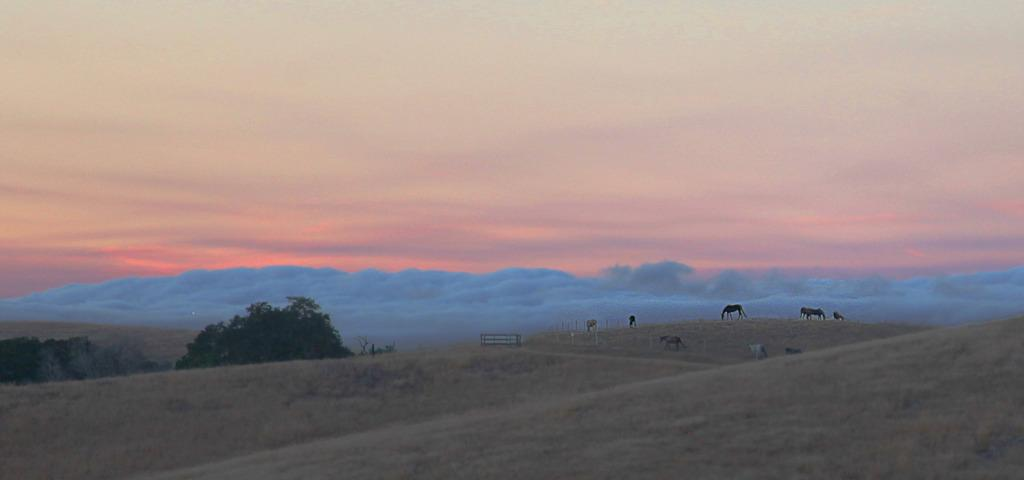What types of living organisms can be seen in the image? There are animals in the image. What structures are present in the image? There are poles in the image. What is located on the path in the image? There is an object on the path in the image. What type of vegetation is on the left side of the image? There are trees on the left side of the image. What is the condition of the sky in the image? The sky is cloudy in the image. How does the growth of the toad affect the poles in the image? There is no toad present in the image, so its growth cannot affect the poles. What type of bit is used by the animals in the image? There is no indication of any bit being used by the animals in the image. 